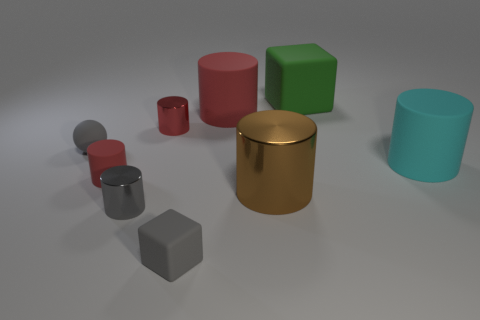What shape is the shiny object that is the same color as the small matte ball?
Ensure brevity in your answer.  Cylinder. What number of gray shiny objects are in front of the large rubber cylinder behind the small gray rubber object behind the cyan matte thing?
Your answer should be compact. 1. There is a metal cylinder that is the same size as the green rubber block; what is its color?
Provide a short and direct response. Brown. What size is the red matte cylinder that is on the right side of the rubber cylinder on the left side of the large red cylinder?
Provide a succinct answer. Large. What size is the other rubber cylinder that is the same color as the tiny matte cylinder?
Offer a very short reply. Large. How many other objects are the same size as the green thing?
Your answer should be very brief. 3. What number of green objects are there?
Offer a very short reply. 1. Is the size of the cyan cylinder the same as the green cube?
Ensure brevity in your answer.  Yes. What number of other objects are there of the same shape as the cyan thing?
Your response must be concise. 5. What is the tiny cylinder that is in front of the red rubber thing left of the big red object made of?
Give a very brief answer. Metal. 